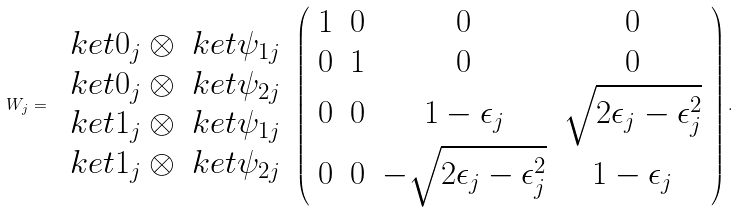<formula> <loc_0><loc_0><loc_500><loc_500>W _ { j } = \begin{array} { c } \ k e t { 0 } _ { j } \otimes \ k e t { \psi _ { 1 j } } \\ \ k e t { 0 } _ { j } \otimes \ k e t { \psi _ { 2 j } } \\ \ k e t { 1 } _ { j } \otimes \ k e t { \psi _ { 1 j } } \\ \ k e t { 1 } _ { j } \otimes \ k e t { \psi _ { 2 j } } \end{array} \, \left ( \begin{array} { c c c c } 1 & 0 & 0 & 0 \\ 0 & 1 & 0 & 0 \\ 0 & 0 & 1 - \epsilon _ { j } & \sqrt { 2 \epsilon _ { j } - \epsilon _ { j } ^ { 2 } } \\ 0 & 0 & - \sqrt { 2 \epsilon _ { j } - \epsilon _ { j } ^ { 2 } } & 1 - \epsilon _ { j } \end{array} \right ) .</formula> 